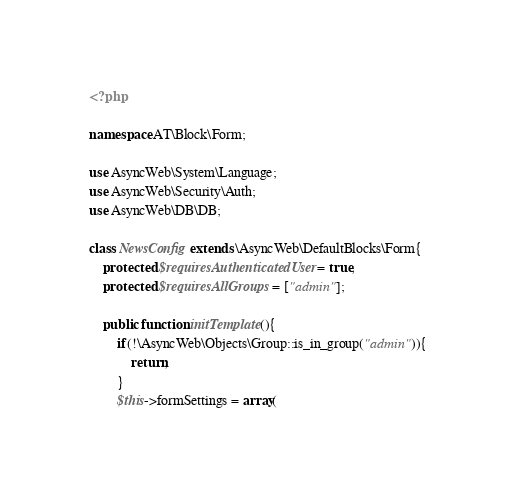<code> <loc_0><loc_0><loc_500><loc_500><_PHP_><?php

namespace AT\Block\Form;

use AsyncWeb\System\Language;
use AsyncWeb\Security\Auth;
use AsyncWeb\DB\DB;

class NewsConfig extends \AsyncWeb\DefaultBlocks\Form{
    protected $requiresAuthenticatedUser = true;
    protected $requiresAllGroups = ["admin"];

	public function initTemplate(){
        if(!\AsyncWeb\Objects\Group::is_in_group("admin")){
            return;
        }
		$this->formSettings = array(</code> 